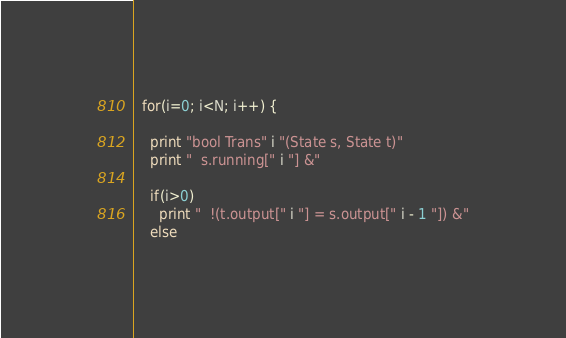<code> <loc_0><loc_0><loc_500><loc_500><_Awk_>  for(i=0; i<N; i++) {
    
    print "bool Trans" i "(State s, State t)"
    print "  s.running[" i "] &"

    if(i>0)
      print "  !(t.output[" i "] = s.output[" i - 1 "]) &"
    else</code> 